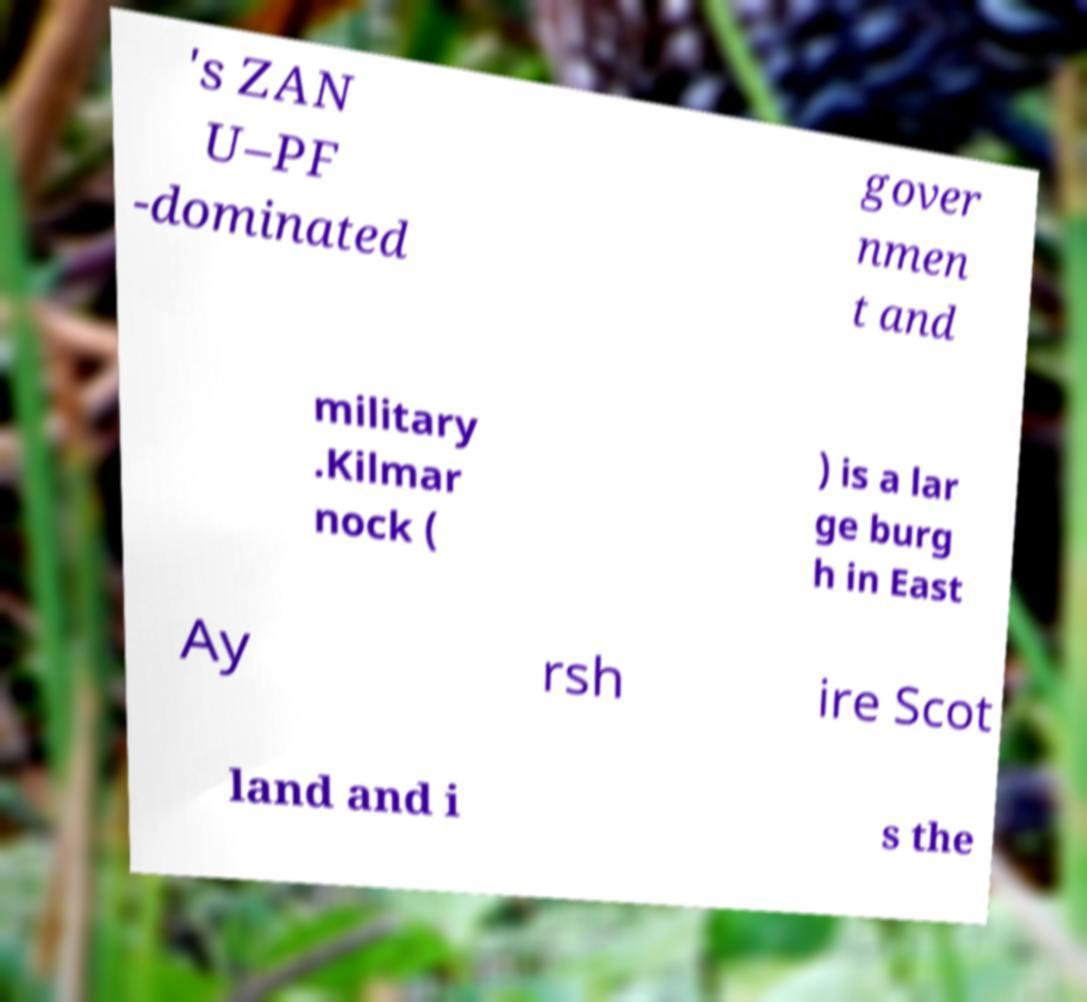Please identify and transcribe the text found in this image. 's ZAN U–PF -dominated gover nmen t and military .Kilmar nock ( ) is a lar ge burg h in East Ay rsh ire Scot land and i s the 